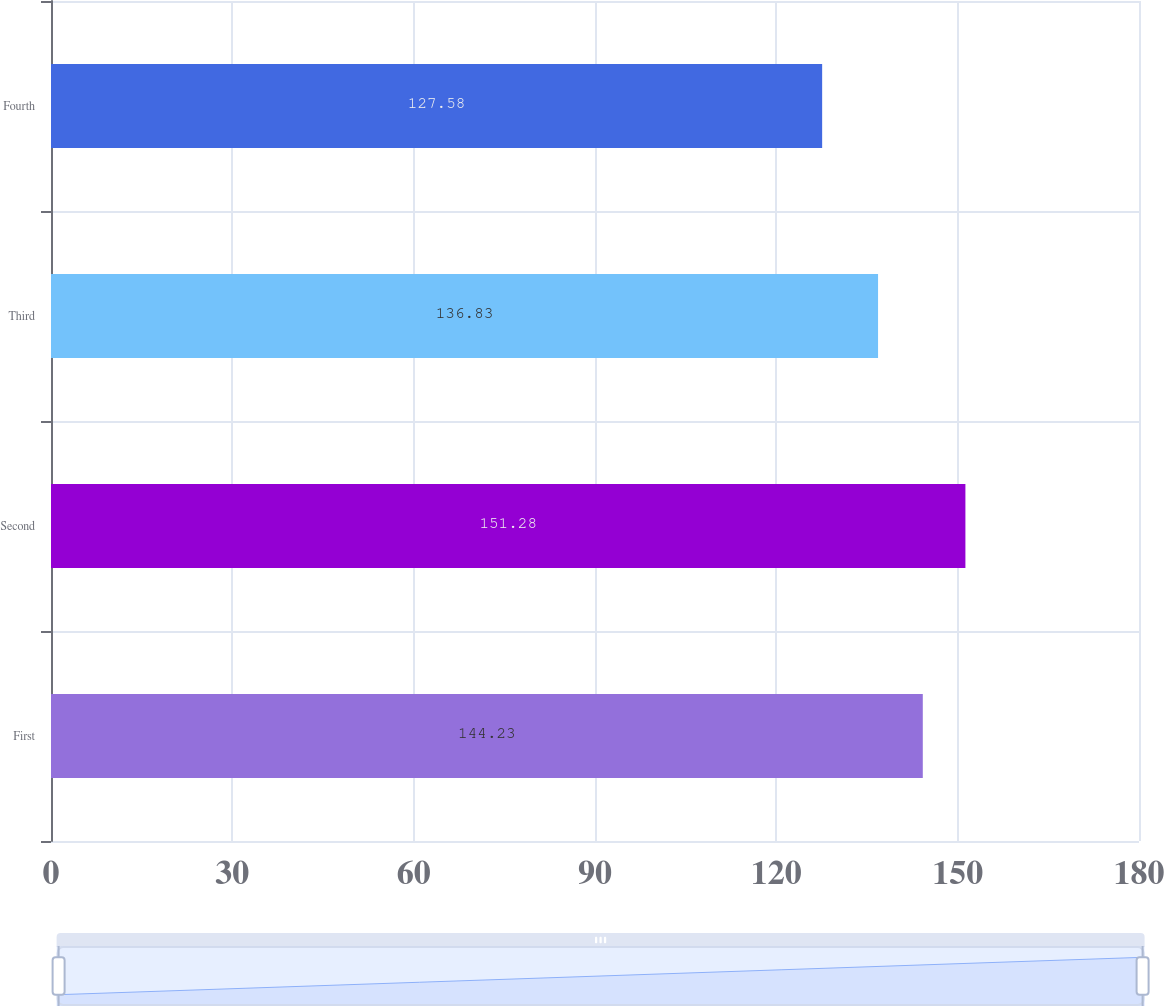Convert chart to OTSL. <chart><loc_0><loc_0><loc_500><loc_500><bar_chart><fcel>First<fcel>Second<fcel>Third<fcel>Fourth<nl><fcel>144.23<fcel>151.28<fcel>136.83<fcel>127.58<nl></chart> 